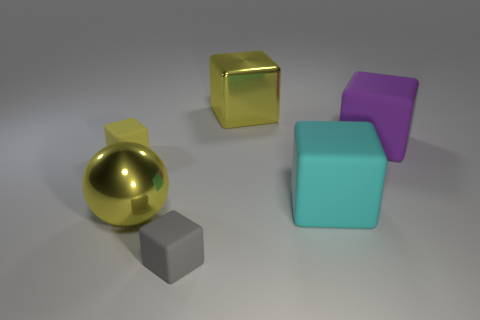Subtract all big yellow blocks. How many blocks are left? 4 Subtract 2 cubes. How many cubes are left? 3 Subtract all gray blocks. How many blocks are left? 4 Add 1 tiny things. How many objects exist? 7 Subtract all cyan cylinders. How many yellow cubes are left? 2 Subtract all brown spheres. Subtract all cyan blocks. How many spheres are left? 1 Subtract all blue spheres. Subtract all large shiny blocks. How many objects are left? 5 Add 3 tiny matte cubes. How many tiny matte cubes are left? 5 Add 3 large yellow blocks. How many large yellow blocks exist? 4 Subtract 1 yellow spheres. How many objects are left? 5 